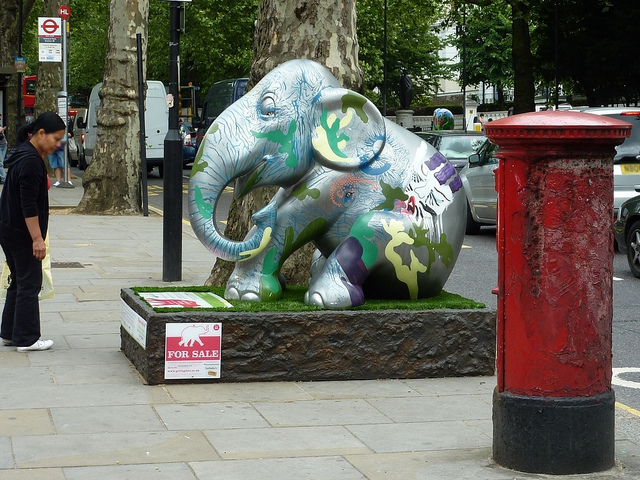What is the significance of the 'For Sale' sign next to the elephant? The 'For Sale' sign suggests that the elephant sculpture may be part of a public art exhibition aimed at fundraising, quite possibly for wildlife conservation or to support artists. It is common for such art pieces to be auctioned off for charity. How is the purchase of such sculptures typically beneficial for conservation? The proceeds from the sale of such sculptures are often donated to conservation organizations. This funds habitat preservation, anti-poaching efforts, and research to help protect species like elephants in the wild. 